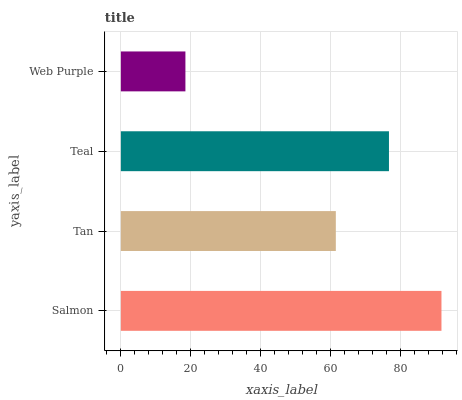Is Web Purple the minimum?
Answer yes or no. Yes. Is Salmon the maximum?
Answer yes or no. Yes. Is Tan the minimum?
Answer yes or no. No. Is Tan the maximum?
Answer yes or no. No. Is Salmon greater than Tan?
Answer yes or no. Yes. Is Tan less than Salmon?
Answer yes or no. Yes. Is Tan greater than Salmon?
Answer yes or no. No. Is Salmon less than Tan?
Answer yes or no. No. Is Teal the high median?
Answer yes or no. Yes. Is Tan the low median?
Answer yes or no. Yes. Is Tan the high median?
Answer yes or no. No. Is Teal the low median?
Answer yes or no. No. 